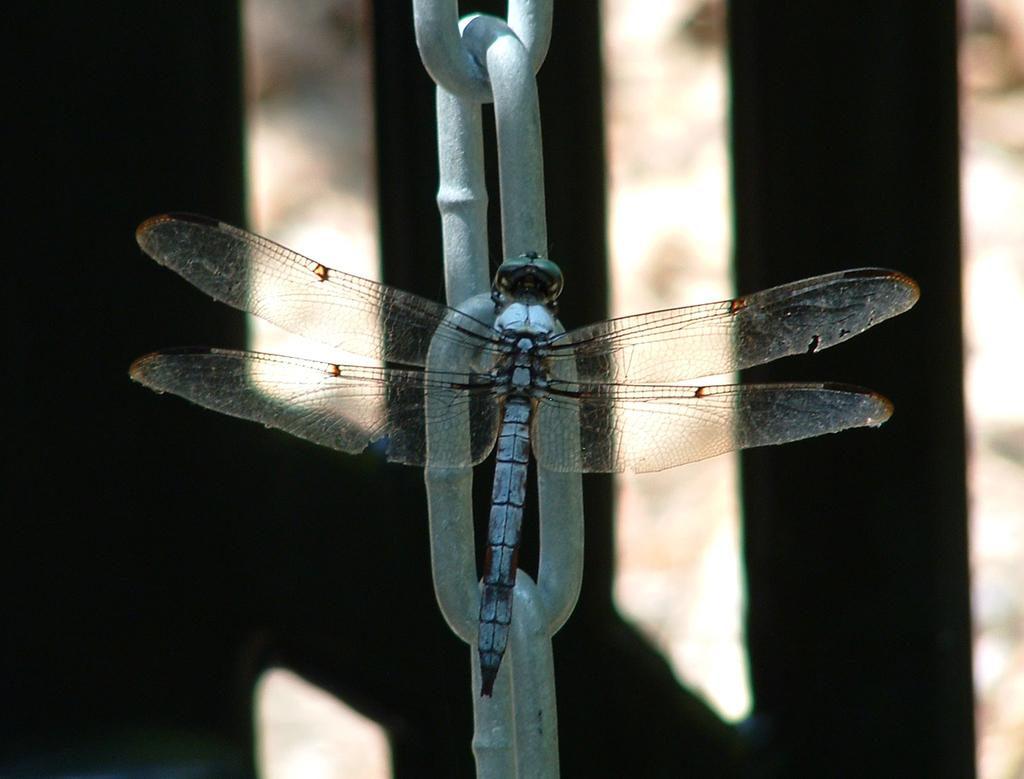What is the main subject of the image? The main subject of the image is a fly on a chain. Can you describe the setting of the image? The setting of the image might include a door or wooden fencing in the background, but it appears blurry. What type of curtain can be seen in the image? There is no curtain present in the image. How does the fly on a chain contribute to the comfort of the environment in the image? The image does not provide any information about the comfort of the environment, and the fly on a chain is not related to comfort. 